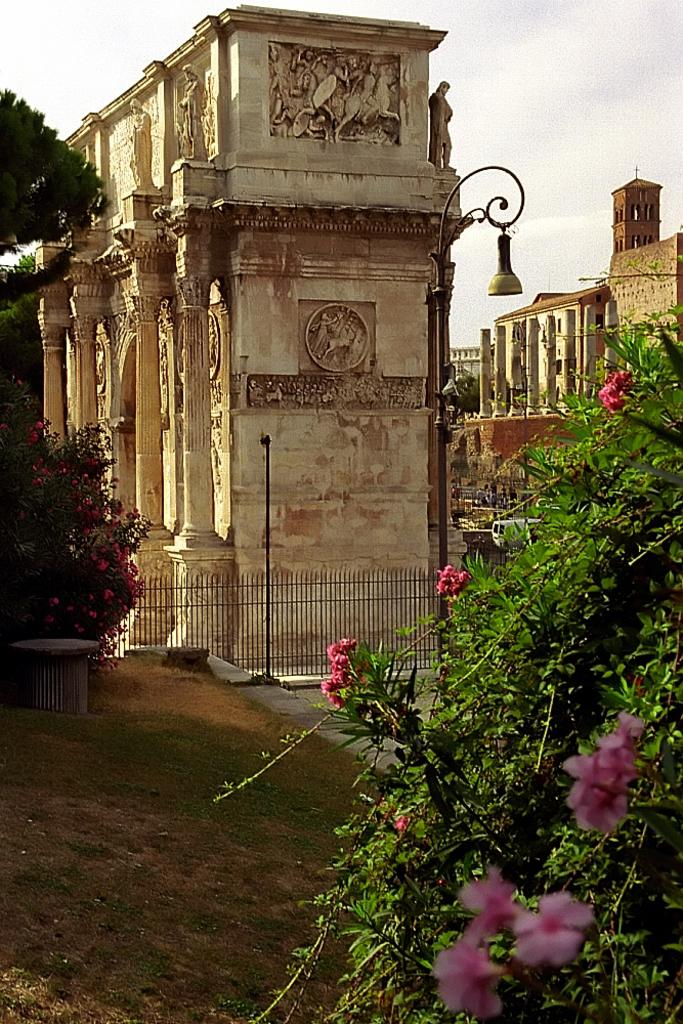What type of structures can be seen in the image? There are buildings in the image. What natural elements are present in the image? There are trees and flowers in the image. What type of barrier can be seen in the image? There is a fence in the image. What objects are located on the right side of the image? There is a pole and a light on the right side of the image. Can you provide a suggestion for the color of the toes in the image? There are no toes present in the image, as it features buildings, trees, flowers, a fence, a pole, and a light. 